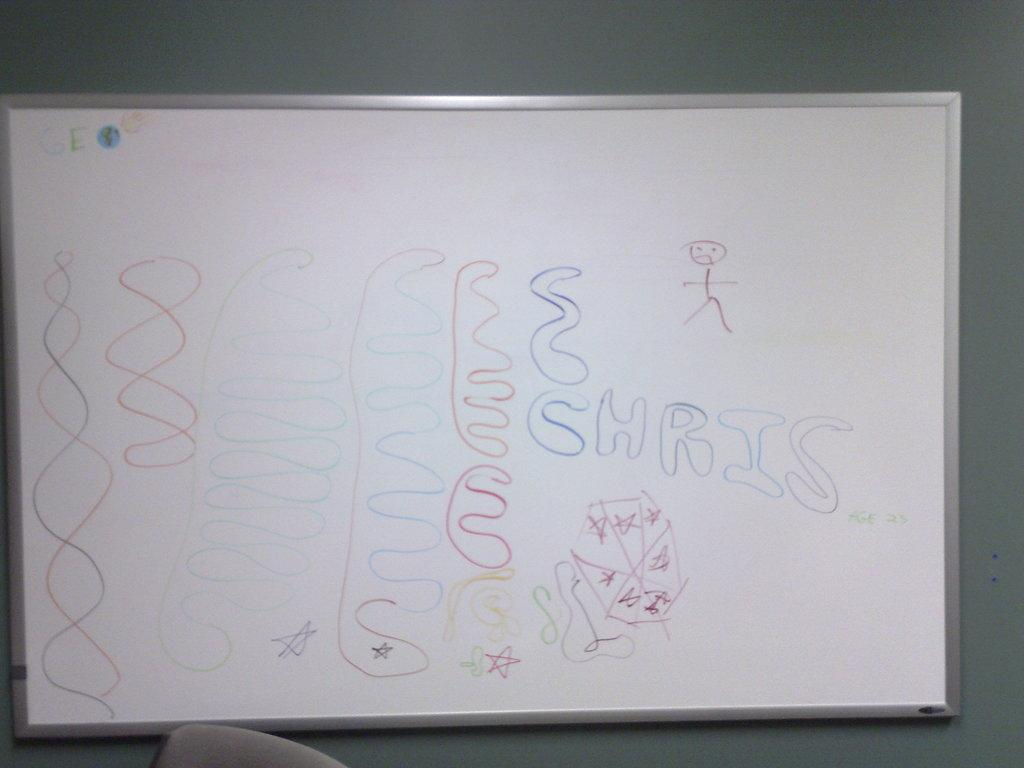<image>
Offer a succinct explanation of the picture presented. A whiteboard with doodles including the name Chris. 